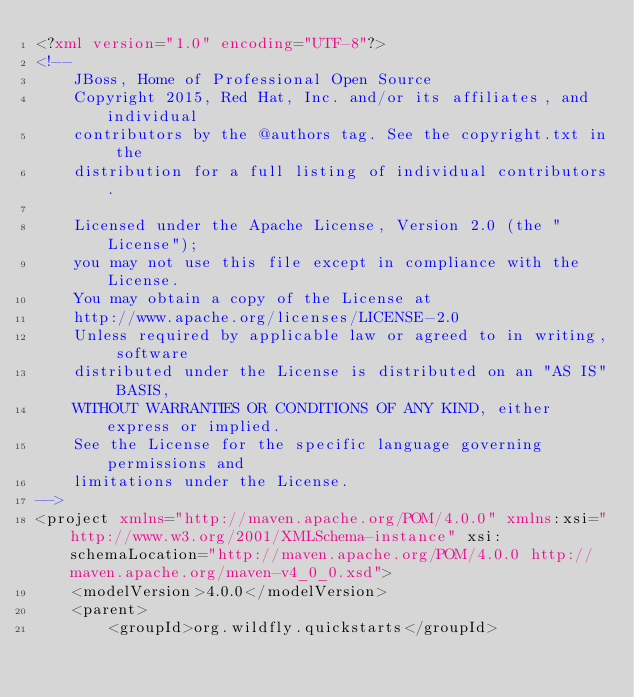<code> <loc_0><loc_0><loc_500><loc_500><_XML_><?xml version="1.0" encoding="UTF-8"?>
<!--
    JBoss, Home of Professional Open Source
    Copyright 2015, Red Hat, Inc. and/or its affiliates, and individual
    contributors by the @authors tag. See the copyright.txt in the
    distribution for a full listing of individual contributors.

    Licensed under the Apache License, Version 2.0 (the "License");
    you may not use this file except in compliance with the License.
    You may obtain a copy of the License at
    http://www.apache.org/licenses/LICENSE-2.0
    Unless required by applicable law or agreed to in writing, software
    distributed under the License is distributed on an "AS IS" BASIS,
    WITHOUT WARRANTIES OR CONDITIONS OF ANY KIND, either express or implied.
    See the License for the specific language governing permissions and
    limitations under the License.
-->
<project xmlns="http://maven.apache.org/POM/4.0.0" xmlns:xsi="http://www.w3.org/2001/XMLSchema-instance" xsi:schemaLocation="http://maven.apache.org/POM/4.0.0 http://maven.apache.org/maven-v4_0_0.xsd">
    <modelVersion>4.0.0</modelVersion>
    <parent>
        <groupId>org.wildfly.quickstarts</groupId></code> 